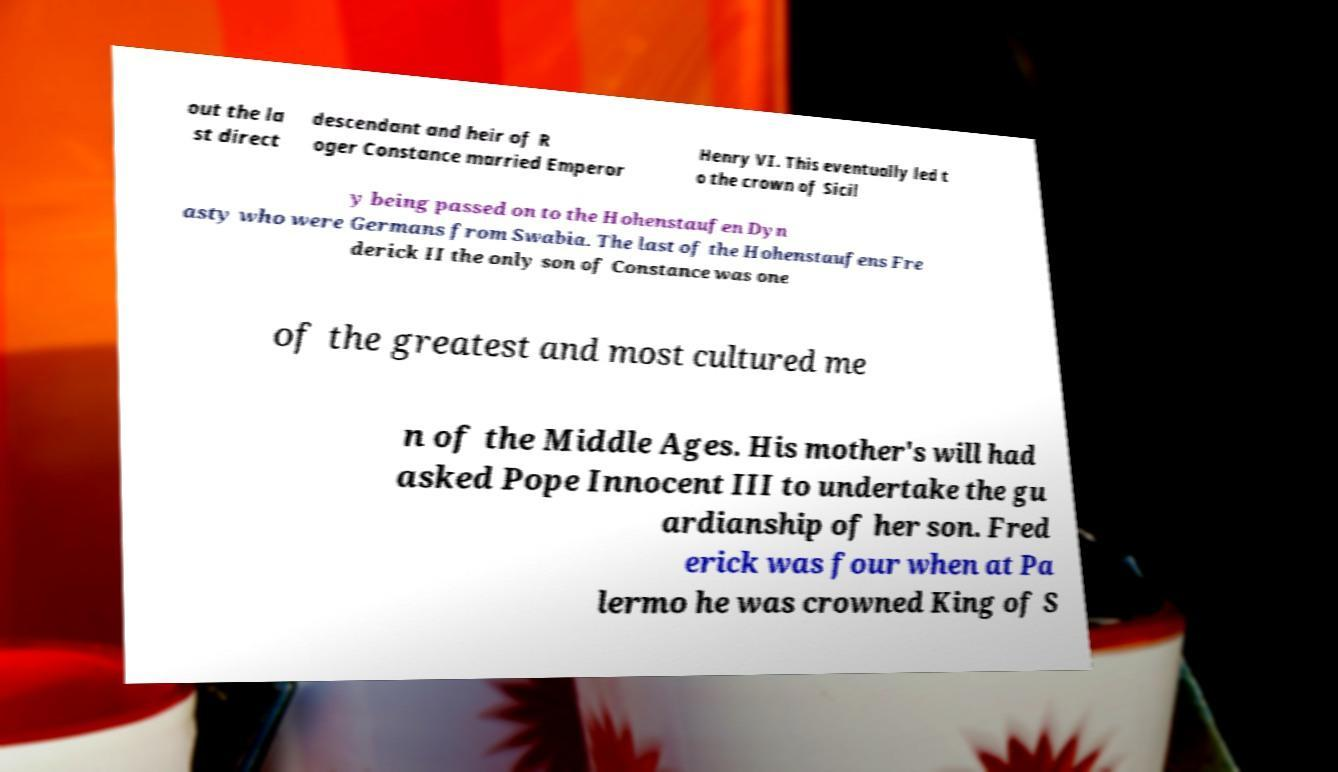I need the written content from this picture converted into text. Can you do that? out the la st direct descendant and heir of R oger Constance married Emperor Henry VI. This eventually led t o the crown of Sicil y being passed on to the Hohenstaufen Dyn asty who were Germans from Swabia. The last of the Hohenstaufens Fre derick II the only son of Constance was one of the greatest and most cultured me n of the Middle Ages. His mother's will had asked Pope Innocent III to undertake the gu ardianship of her son. Fred erick was four when at Pa lermo he was crowned King of S 